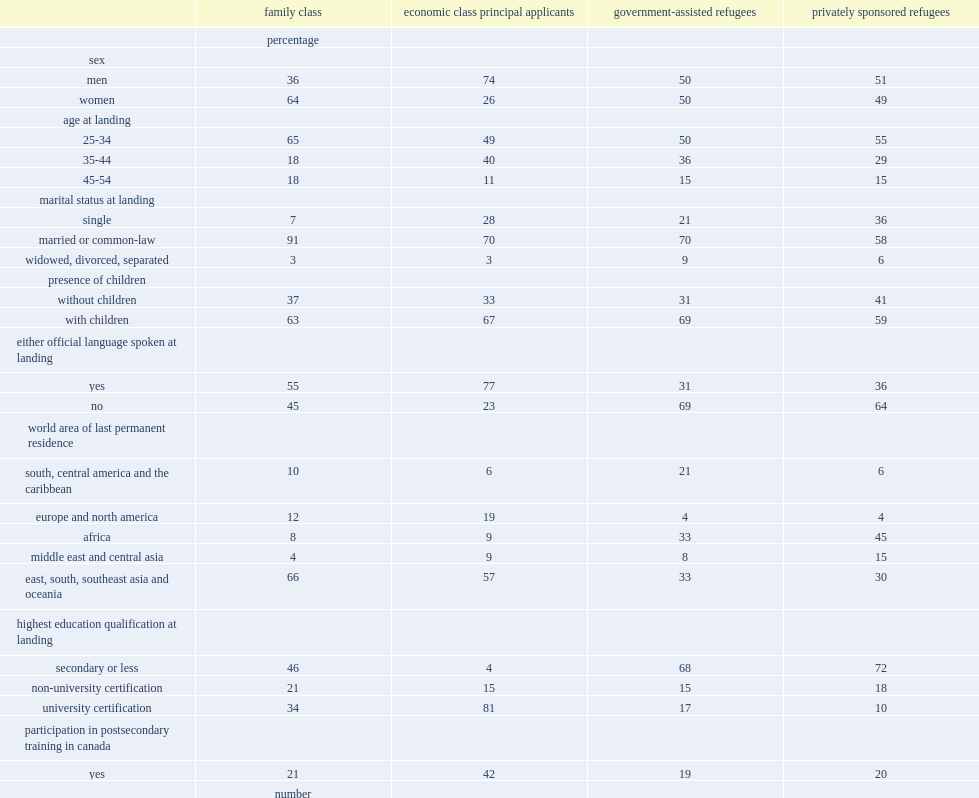Which characteristics are the most likely to report children on their first tax file? Government-assisted refugees. Is the percentage of official language knowledge reported by gars the lowest? Yes. 